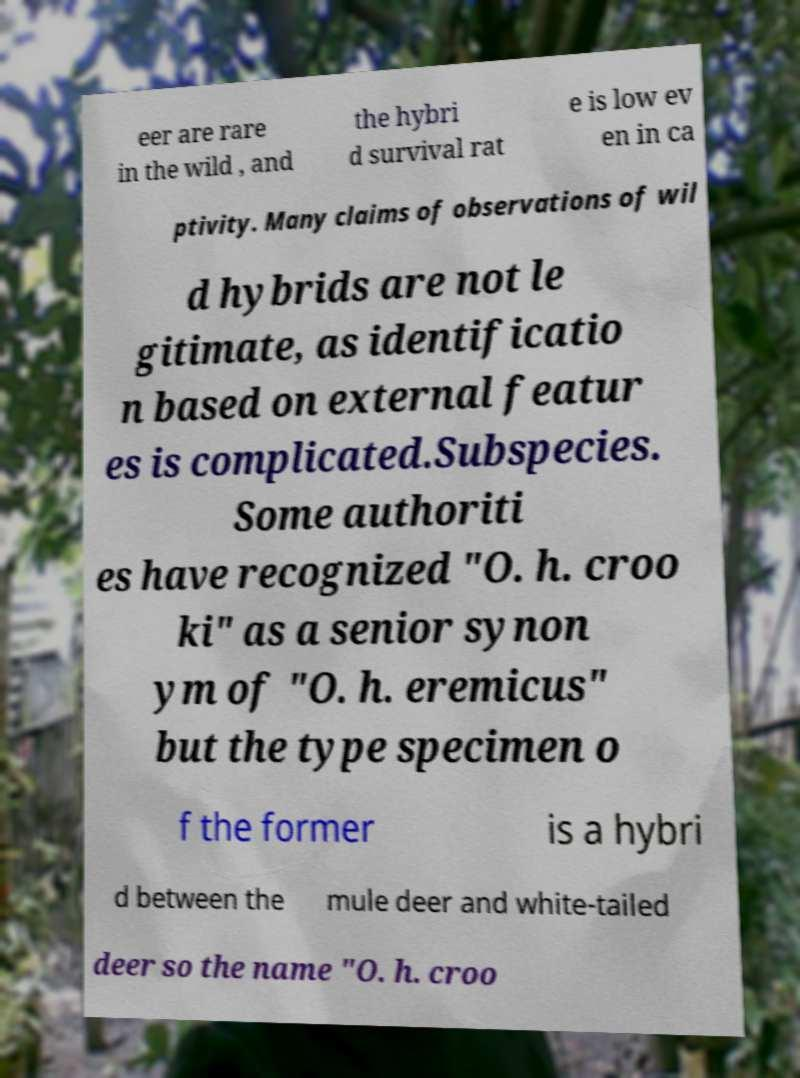Can you read and provide the text displayed in the image?This photo seems to have some interesting text. Can you extract and type it out for me? eer are rare in the wild , and the hybri d survival rat e is low ev en in ca ptivity. Many claims of observations of wil d hybrids are not le gitimate, as identificatio n based on external featur es is complicated.Subspecies. Some authoriti es have recognized "O. h. croo ki" as a senior synon ym of "O. h. eremicus" but the type specimen o f the former is a hybri d between the mule deer and white-tailed deer so the name "O. h. croo 